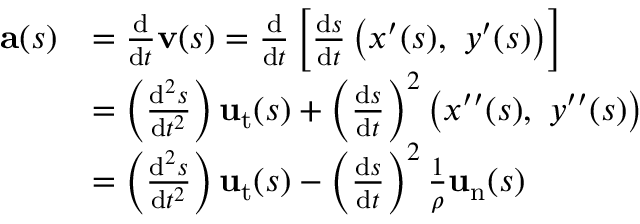Convert formula to latex. <formula><loc_0><loc_0><loc_500><loc_500>{ \begin{array} { r l } { a ( s ) } & { = { \frac { d } { d t } } v ( s ) = { \frac { d } { d t } } \left [ { \frac { d s } { d t } } \left ( x ^ { \prime } ( s ) , \ y ^ { \prime } ( s ) \right ) \right ] } \\ & { = \left ( { \frac { d ^ { 2 } s } { d t ^ { 2 } } } \right ) u _ { t } ( s ) + \left ( { \frac { d s } { d t } } \right ) ^ { 2 } \left ( x ^ { \prime \prime } ( s ) , \ y ^ { \prime \prime } ( s ) \right ) } \\ & { = \left ( { \frac { d ^ { 2 } s } { d t ^ { 2 } } } \right ) u _ { t } ( s ) - \left ( { \frac { d s } { d t } } \right ) ^ { 2 } { \frac { 1 } { \rho } } u _ { n } ( s ) } \end{array} }</formula> 